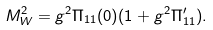Convert formula to latex. <formula><loc_0><loc_0><loc_500><loc_500>M _ { W } ^ { 2 } = g ^ { 2 } \Pi _ { 1 1 } ( 0 ) ( 1 + g ^ { 2 } \Pi _ { 1 1 } ^ { \prime } ) .</formula> 